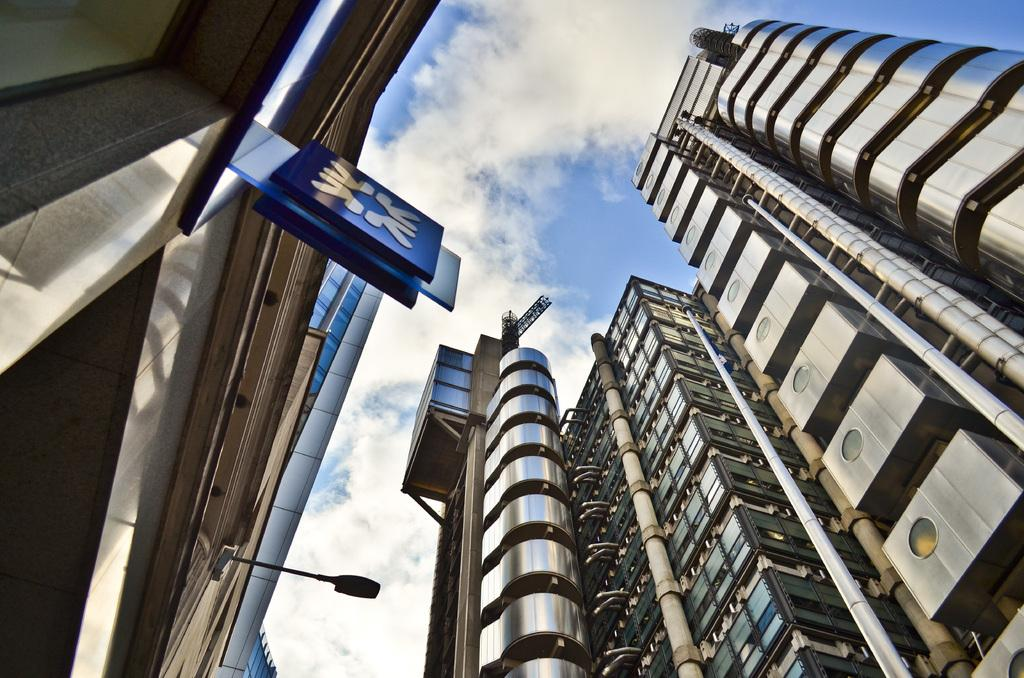What type of structures can be seen in the image? There are buildings in the image. What is the large signage in the image called? There is a hoarding in the image. What can be seen in the sky in the image? There are clouds in the image. What is the source of illumination in the image? Light is visible in the image. What type of music can be heard playing from the pail in the image? There is no pail present in the image, and therefore no music can be heard coming from it. 